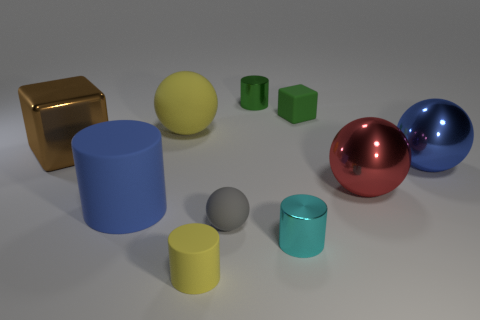Can you describe any color patterns or themes in the image? The image features a harmonious color palette with primary and secondary colors. The spheres are in bold primary colors—red and blue—while the cylinders and cube introduce secondary and tertiary colors like green, yellow, and teal. The arrangement of colors creates a balanced and visually appealing composition, with the metallic brown providing a neutral counterpoint that adds contrast to the scene. 